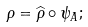Convert formula to latex. <formula><loc_0><loc_0><loc_500><loc_500>\rho = \widehat { \rho } \circ \psi _ { A } ;</formula> 